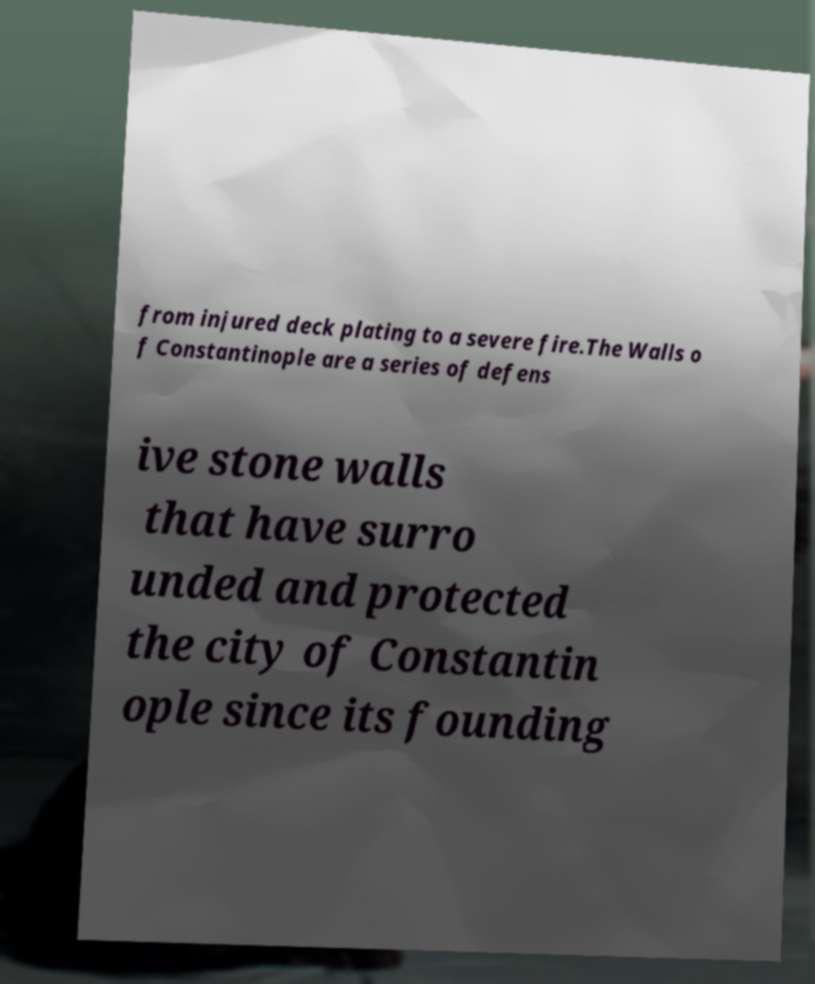Could you extract and type out the text from this image? from injured deck plating to a severe fire.The Walls o f Constantinople are a series of defens ive stone walls that have surro unded and protected the city of Constantin ople since its founding 